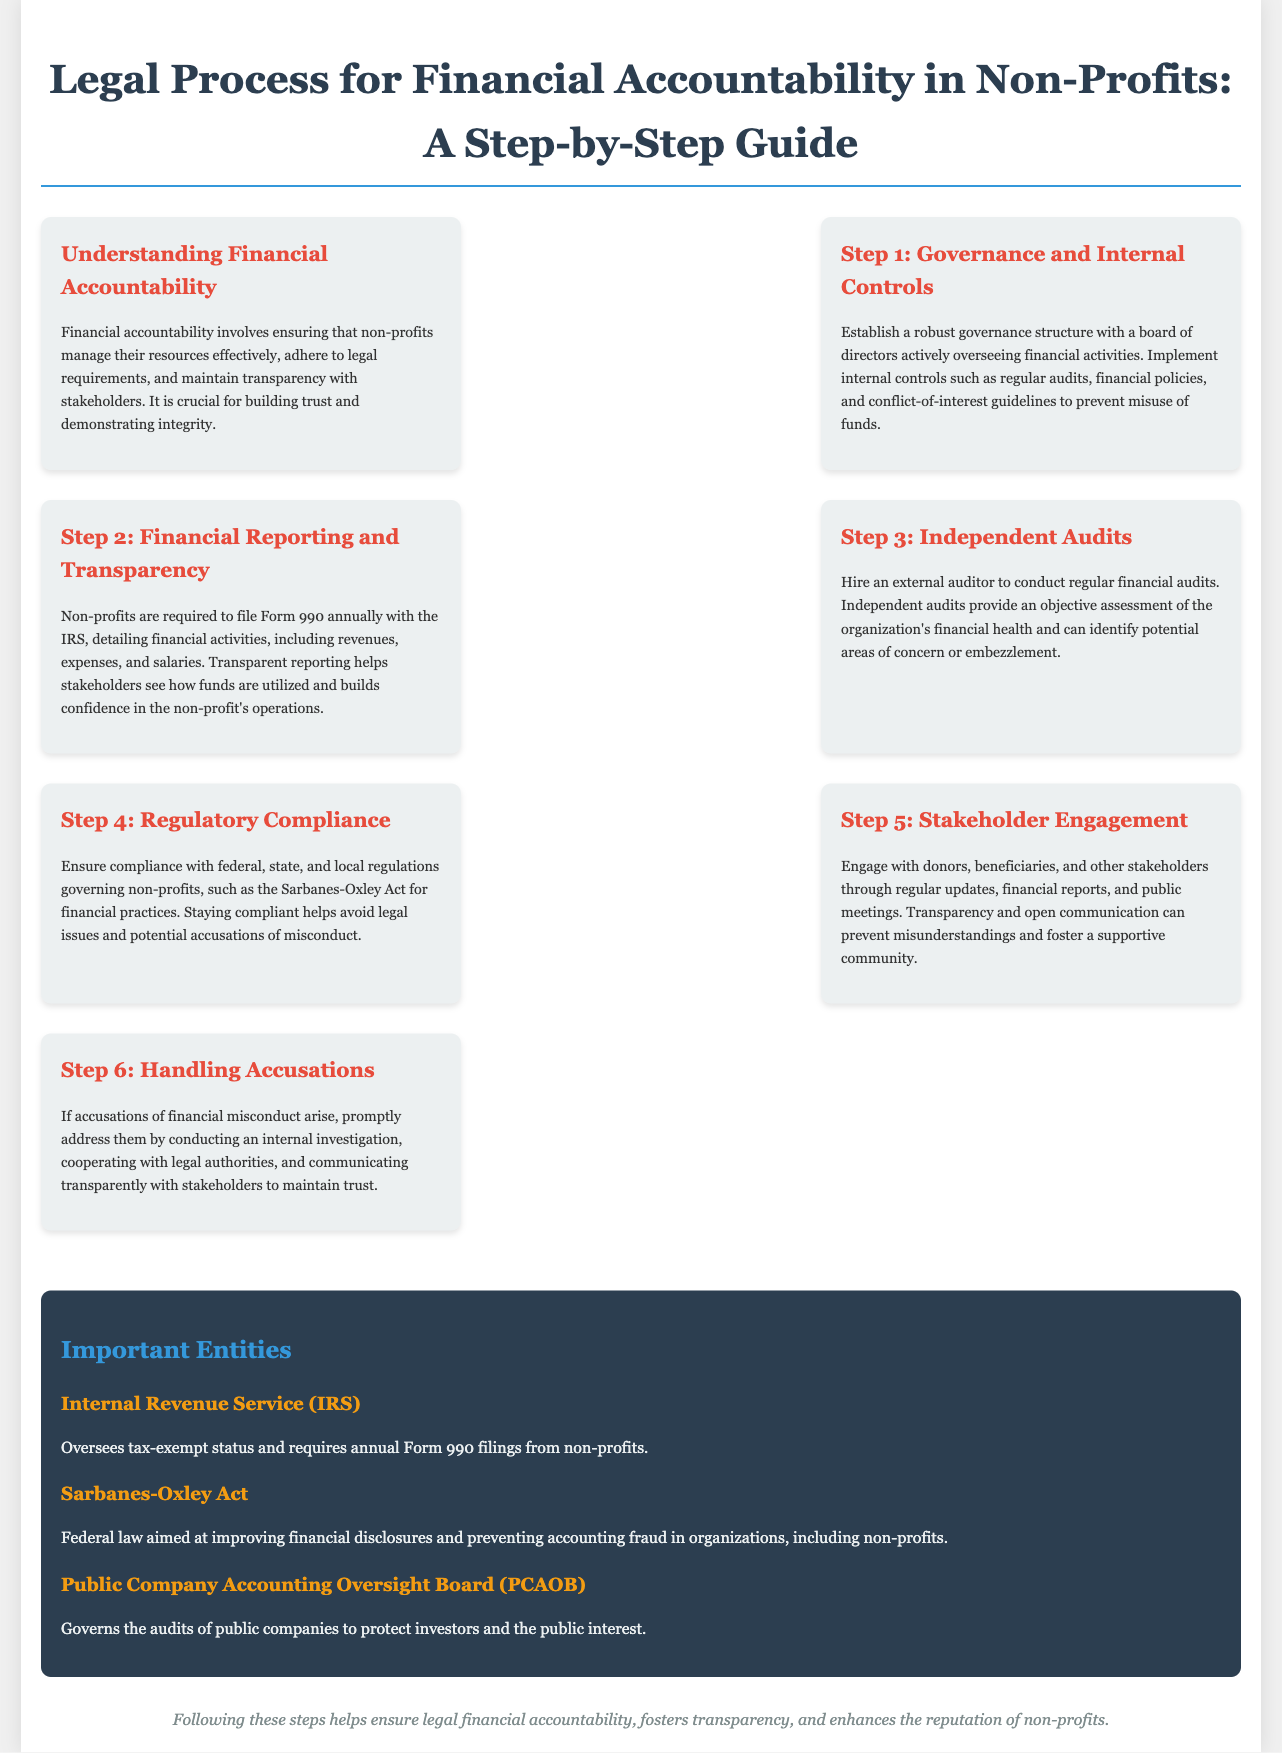What is the title of the document? The title of the document is displayed prominently at the top, which summarizes the main focus.
Answer: Legal Process for Financial Accountability in Non-Profits: A Step-by-Step Guide What is the first step in the process? The first step is described under the section 'Step 1' which outlines initial actions to promote accountability.
Answer: Governance and Internal Controls What form must non-profits file annually? The specific form required for non-profit financial reporting is mentioned in the transparency section.
Answer: Form 990 What is one of the important entities listed? The document lists key entities responsible for oversight or regulation in non-profits, highlighting their significance.
Answer: Internal Revenue Service (IRS) What does the Sarbanes-Oxley Act aim to improve? The purpose of the Sarbanes-Oxley Act is detailed in the entities section regarding its focus on financial practices.
Answer: Financial disclosures Which step involves addressing accusations? This step highlights the actions necessary when facing financial misconduct allegations.
Answer: Step 6: Handling Accusations What is the role of independent audits? The role of independent audits is explained in its own step, focusing on assessment and identification of issues.
Answer: Provide an objective assessment What should stakeholders receive for engagement? The document specifies the type of communication necessary for maintaining good relationships with stakeholders.
Answer: Regular updates How can non-profits prevent misuse of funds? The document provides a method under the governance section to safeguard against financial misconduct.
Answer: Implement internal controls 